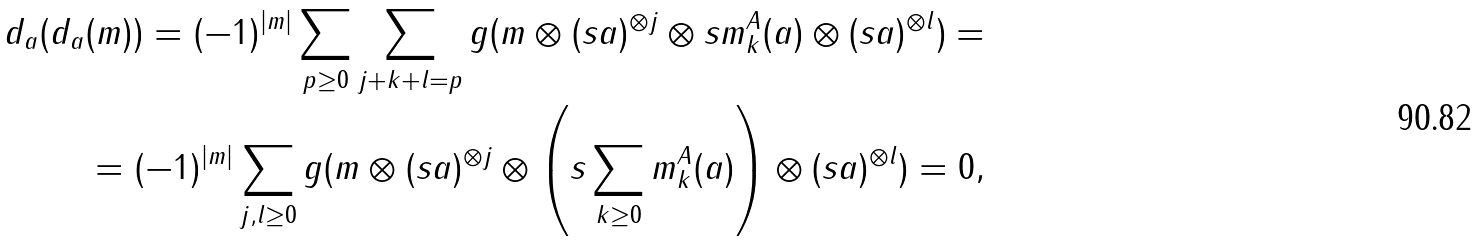<formula> <loc_0><loc_0><loc_500><loc_500>d _ { a } ( d _ { a } ( m ) ) = ( - 1 ) ^ { | m | } \sum _ { p \geq 0 } \sum _ { j + k + l = p } g ( m \otimes ( s a ) ^ { \otimes j } \otimes s m _ { k } ^ { A } ( a ) \otimes ( s a ) ^ { \otimes l } ) = \\ = ( - 1 ) ^ { | m | } \sum _ { j , l \geq 0 } g ( m \otimes ( s a ) ^ { \otimes j } \otimes \left ( s \sum _ { k \geq 0 } m _ { k } ^ { A } ( a ) \right ) \otimes ( s a ) ^ { \otimes l } ) = 0 ,</formula> 